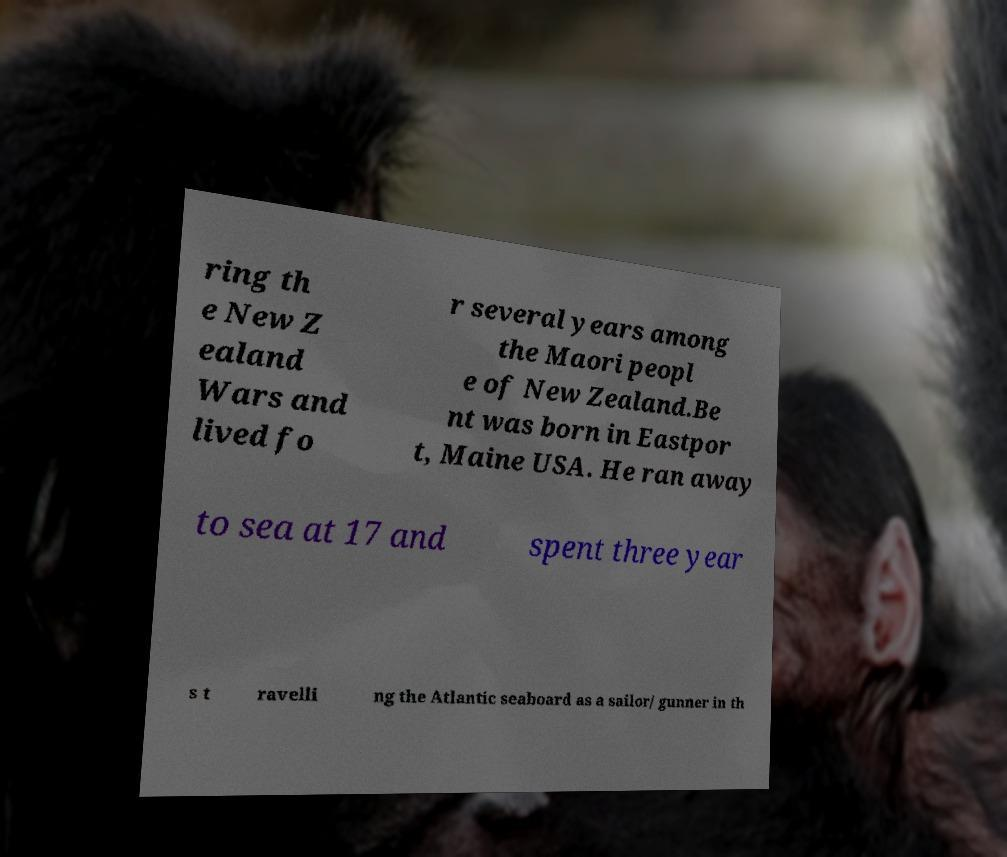Can you read and provide the text displayed in the image?This photo seems to have some interesting text. Can you extract and type it out for me? ring th e New Z ealand Wars and lived fo r several years among the Maori peopl e of New Zealand.Be nt was born in Eastpor t, Maine USA. He ran away to sea at 17 and spent three year s t ravelli ng the Atlantic seaboard as a sailor/ gunner in th 